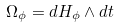Convert formula to latex. <formula><loc_0><loc_0><loc_500><loc_500>\Omega _ { \phi } = d H _ { \phi } \wedge d t</formula> 